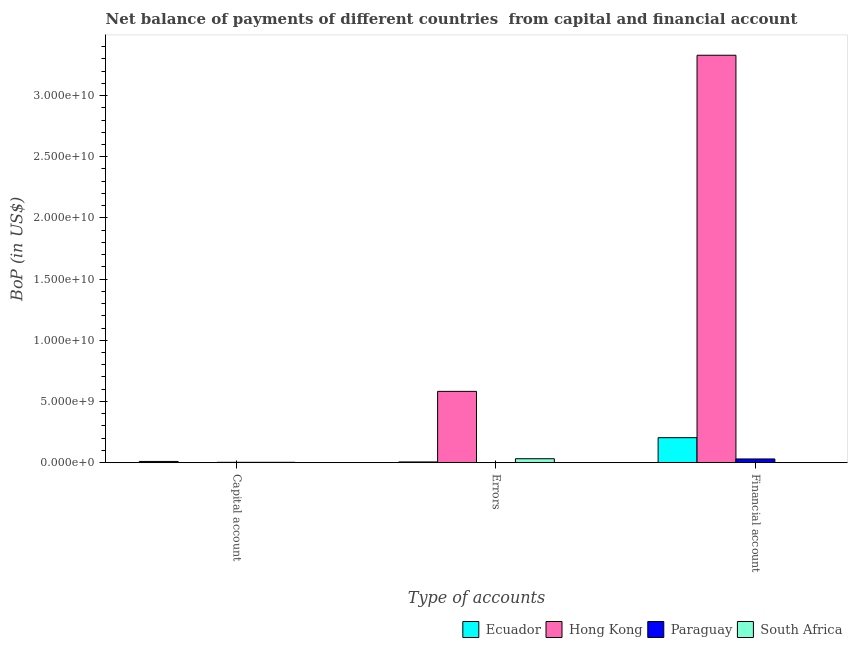How many different coloured bars are there?
Your response must be concise. 4. Are the number of bars on each tick of the X-axis equal?
Your answer should be very brief. Yes. How many bars are there on the 1st tick from the left?
Offer a very short reply. 3. How many bars are there on the 3rd tick from the right?
Ensure brevity in your answer.  3. What is the label of the 1st group of bars from the left?
Ensure brevity in your answer.  Capital account. What is the amount of errors in South Africa?
Your response must be concise. 3.20e+08. Across all countries, what is the maximum amount of net capital account?
Provide a succinct answer. 9.84e+07. Across all countries, what is the minimum amount of errors?
Provide a short and direct response. 0. In which country was the amount of financial account maximum?
Make the answer very short. Hong Kong. What is the total amount of errors in the graph?
Give a very brief answer. 6.20e+09. What is the difference between the amount of net capital account in Ecuador and that in South Africa?
Offer a terse response. 7.05e+07. What is the average amount of net capital account per country?
Your answer should be compact. 3.86e+07. What is the difference between the amount of errors and amount of net capital account in South Africa?
Make the answer very short. 2.92e+08. What is the ratio of the amount of errors in Hong Kong to that in Ecuador?
Your answer should be very brief. 101.47. Is the amount of financial account in Paraguay less than that in Ecuador?
Your answer should be compact. Yes. What is the difference between the highest and the second highest amount of net capital account?
Your answer should be compact. 7.04e+07. What is the difference between the highest and the lowest amount of errors?
Ensure brevity in your answer.  5.83e+09. Is it the case that in every country, the sum of the amount of net capital account and amount of errors is greater than the amount of financial account?
Your answer should be compact. No. How many bars are there?
Offer a terse response. 9. Are all the bars in the graph horizontal?
Your answer should be very brief. No. How many countries are there in the graph?
Your response must be concise. 4. Does the graph contain any zero values?
Keep it short and to the point. Yes. Does the graph contain grids?
Give a very brief answer. No. How are the legend labels stacked?
Offer a terse response. Horizontal. What is the title of the graph?
Your response must be concise. Net balance of payments of different countries  from capital and financial account. Does "Trinidad and Tobago" appear as one of the legend labels in the graph?
Your response must be concise. No. What is the label or title of the X-axis?
Ensure brevity in your answer.  Type of accounts. What is the label or title of the Y-axis?
Make the answer very short. BoP (in US$). What is the BoP (in US$) of Ecuador in Capital account?
Offer a terse response. 9.84e+07. What is the BoP (in US$) in Paraguay in Capital account?
Offer a terse response. 2.80e+07. What is the BoP (in US$) of South Africa in Capital account?
Your answer should be very brief. 2.80e+07. What is the BoP (in US$) of Ecuador in Errors?
Provide a short and direct response. 5.74e+07. What is the BoP (in US$) in Hong Kong in Errors?
Keep it short and to the point. 5.83e+09. What is the BoP (in US$) of South Africa in Errors?
Provide a succinct answer. 3.20e+08. What is the BoP (in US$) in Ecuador in Financial account?
Provide a succinct answer. 2.04e+09. What is the BoP (in US$) in Hong Kong in Financial account?
Offer a terse response. 3.33e+1. What is the BoP (in US$) in Paraguay in Financial account?
Your answer should be compact. 3.02e+08. What is the BoP (in US$) of South Africa in Financial account?
Offer a terse response. 0. Across all Type of accounts, what is the maximum BoP (in US$) of Ecuador?
Ensure brevity in your answer.  2.04e+09. Across all Type of accounts, what is the maximum BoP (in US$) of Hong Kong?
Provide a succinct answer. 3.33e+1. Across all Type of accounts, what is the maximum BoP (in US$) in Paraguay?
Keep it short and to the point. 3.02e+08. Across all Type of accounts, what is the maximum BoP (in US$) in South Africa?
Ensure brevity in your answer.  3.20e+08. Across all Type of accounts, what is the minimum BoP (in US$) in Ecuador?
Your answer should be compact. 5.74e+07. What is the total BoP (in US$) in Ecuador in the graph?
Keep it short and to the point. 2.20e+09. What is the total BoP (in US$) in Hong Kong in the graph?
Your answer should be compact. 3.91e+1. What is the total BoP (in US$) of Paraguay in the graph?
Make the answer very short. 3.30e+08. What is the total BoP (in US$) of South Africa in the graph?
Your response must be concise. 3.48e+08. What is the difference between the BoP (in US$) of Ecuador in Capital account and that in Errors?
Your answer should be very brief. 4.10e+07. What is the difference between the BoP (in US$) of South Africa in Capital account and that in Errors?
Offer a terse response. -2.92e+08. What is the difference between the BoP (in US$) in Ecuador in Capital account and that in Financial account?
Offer a terse response. -1.94e+09. What is the difference between the BoP (in US$) of Paraguay in Capital account and that in Financial account?
Provide a short and direct response. -2.74e+08. What is the difference between the BoP (in US$) in Ecuador in Errors and that in Financial account?
Make the answer very short. -1.98e+09. What is the difference between the BoP (in US$) in Hong Kong in Errors and that in Financial account?
Your response must be concise. -2.75e+1. What is the difference between the BoP (in US$) of Ecuador in Capital account and the BoP (in US$) of Hong Kong in Errors?
Keep it short and to the point. -5.73e+09. What is the difference between the BoP (in US$) of Ecuador in Capital account and the BoP (in US$) of South Africa in Errors?
Offer a terse response. -2.22e+08. What is the difference between the BoP (in US$) in Paraguay in Capital account and the BoP (in US$) in South Africa in Errors?
Ensure brevity in your answer.  -2.92e+08. What is the difference between the BoP (in US$) in Ecuador in Capital account and the BoP (in US$) in Hong Kong in Financial account?
Offer a terse response. -3.32e+1. What is the difference between the BoP (in US$) of Ecuador in Capital account and the BoP (in US$) of Paraguay in Financial account?
Your answer should be compact. -2.03e+08. What is the difference between the BoP (in US$) in Ecuador in Errors and the BoP (in US$) in Hong Kong in Financial account?
Offer a very short reply. -3.32e+1. What is the difference between the BoP (in US$) of Ecuador in Errors and the BoP (in US$) of Paraguay in Financial account?
Your response must be concise. -2.44e+08. What is the difference between the BoP (in US$) of Hong Kong in Errors and the BoP (in US$) of Paraguay in Financial account?
Provide a succinct answer. 5.52e+09. What is the average BoP (in US$) in Ecuador per Type of accounts?
Your response must be concise. 7.32e+08. What is the average BoP (in US$) in Hong Kong per Type of accounts?
Your answer should be very brief. 1.30e+1. What is the average BoP (in US$) of Paraguay per Type of accounts?
Your response must be concise. 1.10e+08. What is the average BoP (in US$) in South Africa per Type of accounts?
Ensure brevity in your answer.  1.16e+08. What is the difference between the BoP (in US$) in Ecuador and BoP (in US$) in Paraguay in Capital account?
Ensure brevity in your answer.  7.04e+07. What is the difference between the BoP (in US$) in Ecuador and BoP (in US$) in South Africa in Capital account?
Provide a succinct answer. 7.05e+07. What is the difference between the BoP (in US$) in Paraguay and BoP (in US$) in South Africa in Capital account?
Make the answer very short. 2.54e+04. What is the difference between the BoP (in US$) in Ecuador and BoP (in US$) in Hong Kong in Errors?
Your response must be concise. -5.77e+09. What is the difference between the BoP (in US$) in Ecuador and BoP (in US$) in South Africa in Errors?
Offer a very short reply. -2.63e+08. What is the difference between the BoP (in US$) in Hong Kong and BoP (in US$) in South Africa in Errors?
Give a very brief answer. 5.51e+09. What is the difference between the BoP (in US$) of Ecuador and BoP (in US$) of Hong Kong in Financial account?
Provide a short and direct response. -3.13e+1. What is the difference between the BoP (in US$) in Ecuador and BoP (in US$) in Paraguay in Financial account?
Your answer should be compact. 1.74e+09. What is the difference between the BoP (in US$) in Hong Kong and BoP (in US$) in Paraguay in Financial account?
Give a very brief answer. 3.30e+1. What is the ratio of the BoP (in US$) of Ecuador in Capital account to that in Errors?
Your answer should be compact. 1.71. What is the ratio of the BoP (in US$) in South Africa in Capital account to that in Errors?
Your response must be concise. 0.09. What is the ratio of the BoP (in US$) of Ecuador in Capital account to that in Financial account?
Provide a succinct answer. 0.05. What is the ratio of the BoP (in US$) of Paraguay in Capital account to that in Financial account?
Your response must be concise. 0.09. What is the ratio of the BoP (in US$) of Ecuador in Errors to that in Financial account?
Your answer should be compact. 0.03. What is the ratio of the BoP (in US$) in Hong Kong in Errors to that in Financial account?
Provide a short and direct response. 0.17. What is the difference between the highest and the second highest BoP (in US$) in Ecuador?
Provide a succinct answer. 1.94e+09. What is the difference between the highest and the lowest BoP (in US$) of Ecuador?
Your answer should be very brief. 1.98e+09. What is the difference between the highest and the lowest BoP (in US$) in Hong Kong?
Make the answer very short. 3.33e+1. What is the difference between the highest and the lowest BoP (in US$) in Paraguay?
Provide a short and direct response. 3.02e+08. What is the difference between the highest and the lowest BoP (in US$) of South Africa?
Give a very brief answer. 3.20e+08. 